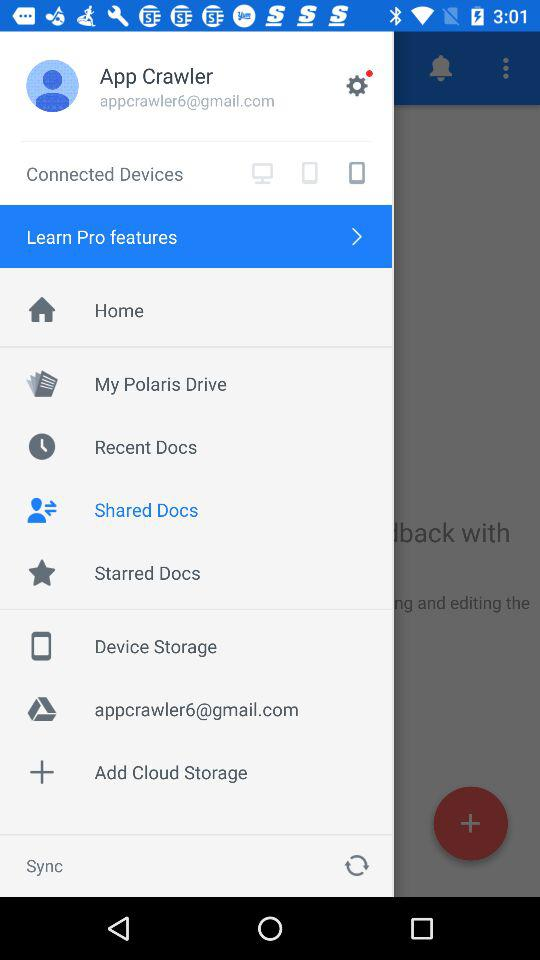What is the name of the person? The name is App Crawler. 